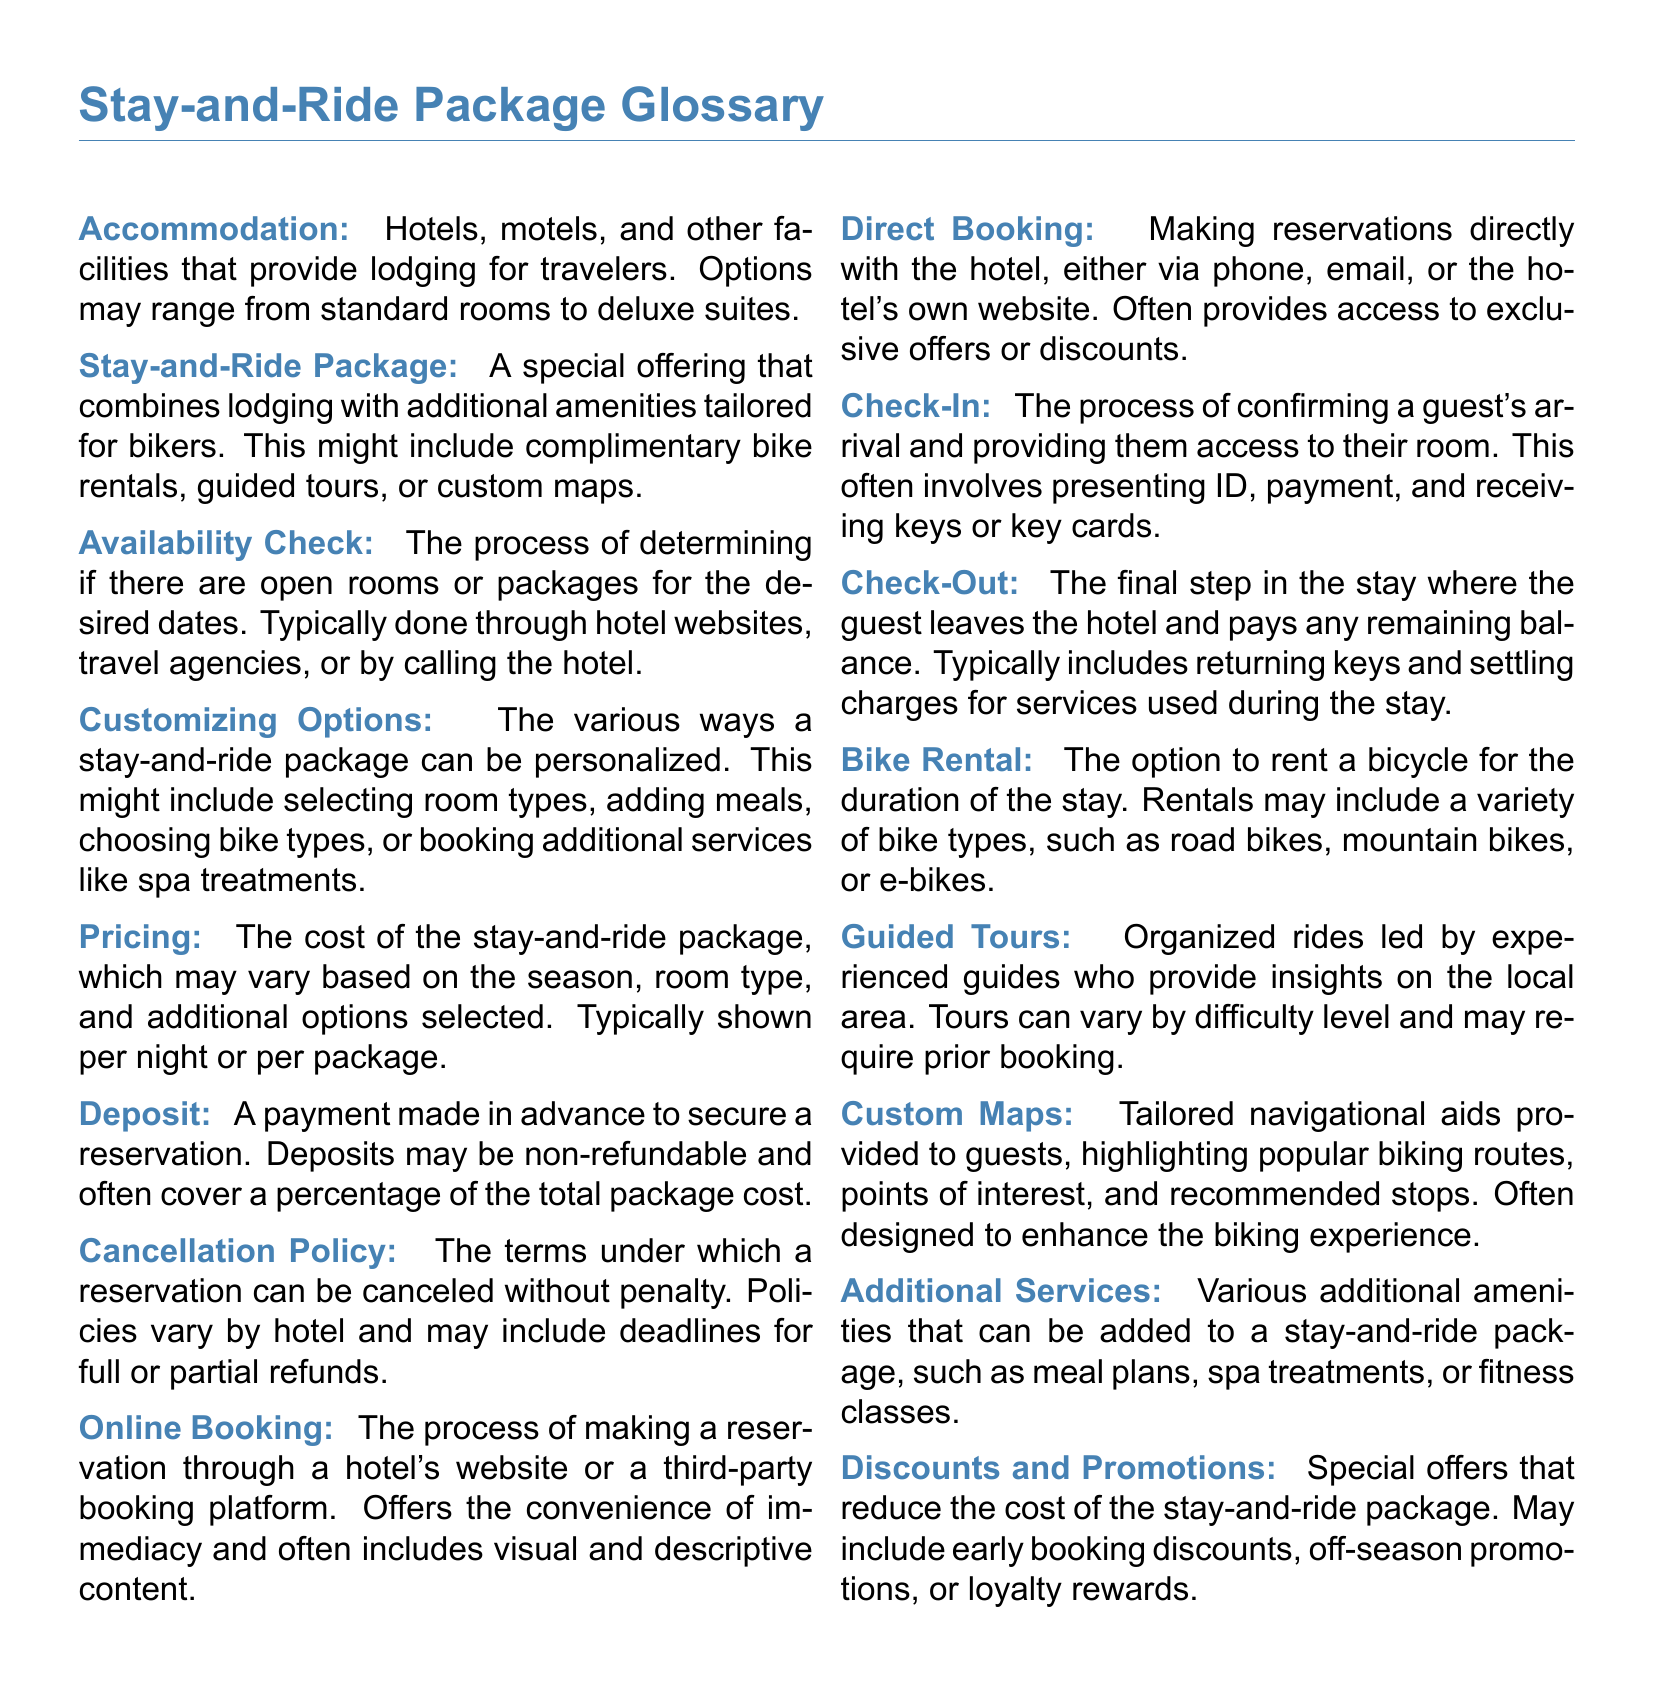What is a Stay-and-Ride Package? A Stay-and-Ride Package is a special offering that combines lodging with additional amenities tailored for bikers.
Answer: A special offering that combines lodging with additional amenities tailored for bikers What is the purpose of the Availability Check? The Availability Check is the process of determining if there are open rooms or packages for the desired dates.
Answer: Determining if there are open rooms or packages What does the term Deposit refer to? The Deposit is a payment made in advance to secure a reservation, often covering a percentage of the total package cost.
Answer: A payment made in advance to secure a reservation What do Custom Maps provide? Custom Maps provide tailored navigational aids highlighting popular biking routes, points of interest, and recommended stops.
Answer: Tailored navigational aids highlighting popular biking routes What options can be included in Additional Services? Additional Services can include amenities such as meal plans, spa treatments, or fitness classes.
Answer: Meal plans, spa treatments, or fitness classes What process is involved in Check-Out? Check-Out involves the guest leaving the hotel and paying any remaining balance, returning keys, and settling charges.
Answer: Guest leaving the hotel and paying any remaining balance Are discounts available for Stay-and-Ride Packages? Yes, Discounts and Promotions can reduce the cost of the stay-and-ride package through various special offers.
Answer: Yes, Discounts and Promotions are available What are Guided Tours? Guided Tours are organized rides led by experienced guides providing insights on the local area.
Answer: Organized rides led by experienced guides What is the role of Direct Booking? Direct Booking means making reservations directly with the hotel, which often provides access to exclusive offers.
Answer: Making reservations directly with the hotel 